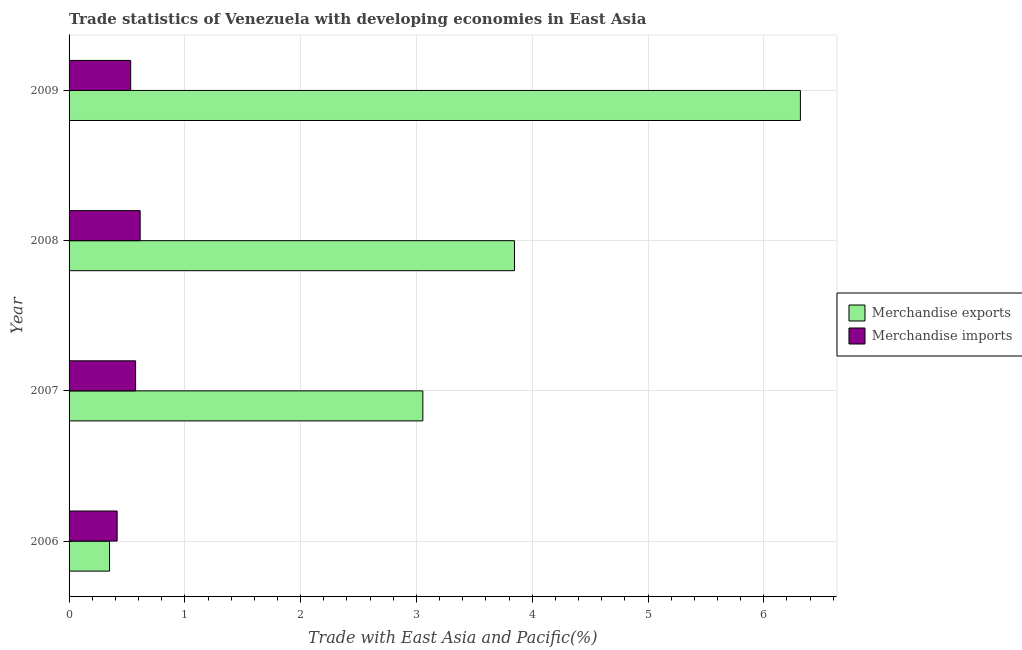How many different coloured bars are there?
Make the answer very short. 2. Are the number of bars per tick equal to the number of legend labels?
Give a very brief answer. Yes. How many bars are there on the 4th tick from the bottom?
Keep it short and to the point. 2. What is the label of the 1st group of bars from the top?
Your answer should be very brief. 2009. What is the merchandise exports in 2009?
Your response must be concise. 6.32. Across all years, what is the maximum merchandise imports?
Your answer should be very brief. 0.61. Across all years, what is the minimum merchandise imports?
Ensure brevity in your answer.  0.42. What is the total merchandise exports in the graph?
Your answer should be very brief. 13.57. What is the difference between the merchandise exports in 2008 and that in 2009?
Provide a short and direct response. -2.47. What is the difference between the merchandise imports in 2009 and the merchandise exports in 2006?
Ensure brevity in your answer.  0.18. What is the average merchandise imports per year?
Your response must be concise. 0.53. In the year 2006, what is the difference between the merchandise imports and merchandise exports?
Provide a succinct answer. 0.07. What is the ratio of the merchandise exports in 2006 to that in 2007?
Keep it short and to the point. 0.11. What is the difference between the highest and the second highest merchandise imports?
Offer a terse response. 0.04. What does the 2nd bar from the top in 2008 represents?
Your answer should be compact. Merchandise exports. How many bars are there?
Your answer should be compact. 8. How many years are there in the graph?
Provide a short and direct response. 4. Are the values on the major ticks of X-axis written in scientific E-notation?
Make the answer very short. No. Does the graph contain any zero values?
Your answer should be very brief. No. Where does the legend appear in the graph?
Your answer should be very brief. Center right. What is the title of the graph?
Give a very brief answer. Trade statistics of Venezuela with developing economies in East Asia. Does "Urban" appear as one of the legend labels in the graph?
Provide a succinct answer. No. What is the label or title of the X-axis?
Ensure brevity in your answer.  Trade with East Asia and Pacific(%). What is the Trade with East Asia and Pacific(%) in Merchandise exports in 2006?
Your answer should be compact. 0.35. What is the Trade with East Asia and Pacific(%) in Merchandise imports in 2006?
Make the answer very short. 0.42. What is the Trade with East Asia and Pacific(%) in Merchandise exports in 2007?
Offer a very short reply. 3.06. What is the Trade with East Asia and Pacific(%) in Merchandise imports in 2007?
Your answer should be very brief. 0.57. What is the Trade with East Asia and Pacific(%) in Merchandise exports in 2008?
Your response must be concise. 3.85. What is the Trade with East Asia and Pacific(%) in Merchandise imports in 2008?
Your answer should be very brief. 0.61. What is the Trade with East Asia and Pacific(%) of Merchandise exports in 2009?
Make the answer very short. 6.32. What is the Trade with East Asia and Pacific(%) of Merchandise imports in 2009?
Keep it short and to the point. 0.53. Across all years, what is the maximum Trade with East Asia and Pacific(%) of Merchandise exports?
Your answer should be very brief. 6.32. Across all years, what is the maximum Trade with East Asia and Pacific(%) in Merchandise imports?
Offer a terse response. 0.61. Across all years, what is the minimum Trade with East Asia and Pacific(%) of Merchandise exports?
Your response must be concise. 0.35. Across all years, what is the minimum Trade with East Asia and Pacific(%) in Merchandise imports?
Offer a terse response. 0.42. What is the total Trade with East Asia and Pacific(%) in Merchandise exports in the graph?
Your answer should be compact. 13.57. What is the total Trade with East Asia and Pacific(%) in Merchandise imports in the graph?
Offer a very short reply. 2.14. What is the difference between the Trade with East Asia and Pacific(%) in Merchandise exports in 2006 and that in 2007?
Your answer should be compact. -2.71. What is the difference between the Trade with East Asia and Pacific(%) of Merchandise imports in 2006 and that in 2007?
Provide a short and direct response. -0.16. What is the difference between the Trade with East Asia and Pacific(%) in Merchandise exports in 2006 and that in 2008?
Your answer should be very brief. -3.5. What is the difference between the Trade with East Asia and Pacific(%) of Merchandise imports in 2006 and that in 2008?
Offer a terse response. -0.2. What is the difference between the Trade with East Asia and Pacific(%) of Merchandise exports in 2006 and that in 2009?
Offer a terse response. -5.97. What is the difference between the Trade with East Asia and Pacific(%) in Merchandise imports in 2006 and that in 2009?
Your answer should be very brief. -0.12. What is the difference between the Trade with East Asia and Pacific(%) in Merchandise exports in 2007 and that in 2008?
Keep it short and to the point. -0.79. What is the difference between the Trade with East Asia and Pacific(%) in Merchandise imports in 2007 and that in 2008?
Ensure brevity in your answer.  -0.04. What is the difference between the Trade with East Asia and Pacific(%) in Merchandise exports in 2007 and that in 2009?
Offer a terse response. -3.26. What is the difference between the Trade with East Asia and Pacific(%) in Merchandise imports in 2007 and that in 2009?
Keep it short and to the point. 0.04. What is the difference between the Trade with East Asia and Pacific(%) of Merchandise exports in 2008 and that in 2009?
Offer a very short reply. -2.47. What is the difference between the Trade with East Asia and Pacific(%) of Merchandise imports in 2008 and that in 2009?
Offer a terse response. 0.08. What is the difference between the Trade with East Asia and Pacific(%) of Merchandise exports in 2006 and the Trade with East Asia and Pacific(%) of Merchandise imports in 2007?
Your answer should be very brief. -0.23. What is the difference between the Trade with East Asia and Pacific(%) of Merchandise exports in 2006 and the Trade with East Asia and Pacific(%) of Merchandise imports in 2008?
Offer a very short reply. -0.26. What is the difference between the Trade with East Asia and Pacific(%) of Merchandise exports in 2006 and the Trade with East Asia and Pacific(%) of Merchandise imports in 2009?
Your answer should be compact. -0.18. What is the difference between the Trade with East Asia and Pacific(%) of Merchandise exports in 2007 and the Trade with East Asia and Pacific(%) of Merchandise imports in 2008?
Offer a very short reply. 2.44. What is the difference between the Trade with East Asia and Pacific(%) of Merchandise exports in 2007 and the Trade with East Asia and Pacific(%) of Merchandise imports in 2009?
Your response must be concise. 2.52. What is the difference between the Trade with East Asia and Pacific(%) in Merchandise exports in 2008 and the Trade with East Asia and Pacific(%) in Merchandise imports in 2009?
Offer a very short reply. 3.31. What is the average Trade with East Asia and Pacific(%) of Merchandise exports per year?
Your response must be concise. 3.39. What is the average Trade with East Asia and Pacific(%) of Merchandise imports per year?
Make the answer very short. 0.53. In the year 2006, what is the difference between the Trade with East Asia and Pacific(%) of Merchandise exports and Trade with East Asia and Pacific(%) of Merchandise imports?
Ensure brevity in your answer.  -0.07. In the year 2007, what is the difference between the Trade with East Asia and Pacific(%) of Merchandise exports and Trade with East Asia and Pacific(%) of Merchandise imports?
Give a very brief answer. 2.48. In the year 2008, what is the difference between the Trade with East Asia and Pacific(%) in Merchandise exports and Trade with East Asia and Pacific(%) in Merchandise imports?
Keep it short and to the point. 3.23. In the year 2009, what is the difference between the Trade with East Asia and Pacific(%) in Merchandise exports and Trade with East Asia and Pacific(%) in Merchandise imports?
Give a very brief answer. 5.78. What is the ratio of the Trade with East Asia and Pacific(%) of Merchandise exports in 2006 to that in 2007?
Provide a short and direct response. 0.11. What is the ratio of the Trade with East Asia and Pacific(%) of Merchandise imports in 2006 to that in 2007?
Keep it short and to the point. 0.72. What is the ratio of the Trade with East Asia and Pacific(%) of Merchandise exports in 2006 to that in 2008?
Your answer should be compact. 0.09. What is the ratio of the Trade with East Asia and Pacific(%) of Merchandise imports in 2006 to that in 2008?
Give a very brief answer. 0.68. What is the ratio of the Trade with East Asia and Pacific(%) in Merchandise exports in 2006 to that in 2009?
Offer a terse response. 0.06. What is the ratio of the Trade with East Asia and Pacific(%) in Merchandise imports in 2006 to that in 2009?
Your response must be concise. 0.78. What is the ratio of the Trade with East Asia and Pacific(%) in Merchandise exports in 2007 to that in 2008?
Give a very brief answer. 0.79. What is the ratio of the Trade with East Asia and Pacific(%) of Merchandise imports in 2007 to that in 2008?
Keep it short and to the point. 0.94. What is the ratio of the Trade with East Asia and Pacific(%) in Merchandise exports in 2007 to that in 2009?
Offer a very short reply. 0.48. What is the ratio of the Trade with East Asia and Pacific(%) in Merchandise imports in 2007 to that in 2009?
Keep it short and to the point. 1.08. What is the ratio of the Trade with East Asia and Pacific(%) in Merchandise exports in 2008 to that in 2009?
Your response must be concise. 0.61. What is the ratio of the Trade with East Asia and Pacific(%) in Merchandise imports in 2008 to that in 2009?
Your answer should be compact. 1.15. What is the difference between the highest and the second highest Trade with East Asia and Pacific(%) in Merchandise exports?
Your response must be concise. 2.47. What is the difference between the highest and the second highest Trade with East Asia and Pacific(%) in Merchandise imports?
Make the answer very short. 0.04. What is the difference between the highest and the lowest Trade with East Asia and Pacific(%) of Merchandise exports?
Provide a succinct answer. 5.97. What is the difference between the highest and the lowest Trade with East Asia and Pacific(%) of Merchandise imports?
Your answer should be compact. 0.2. 